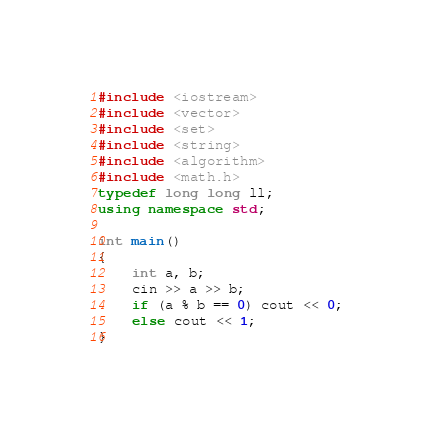<code> <loc_0><loc_0><loc_500><loc_500><_C++_>#include <iostream>
#include <vector>
#include <set>
#include <string>
#include <algorithm>
#include <math.h>
typedef long long ll;
using namespace std;

int main()
{
	int a, b;
	cin >> a >> b;
	if (a % b == 0) cout << 0;
	else cout << 1;
}</code> 